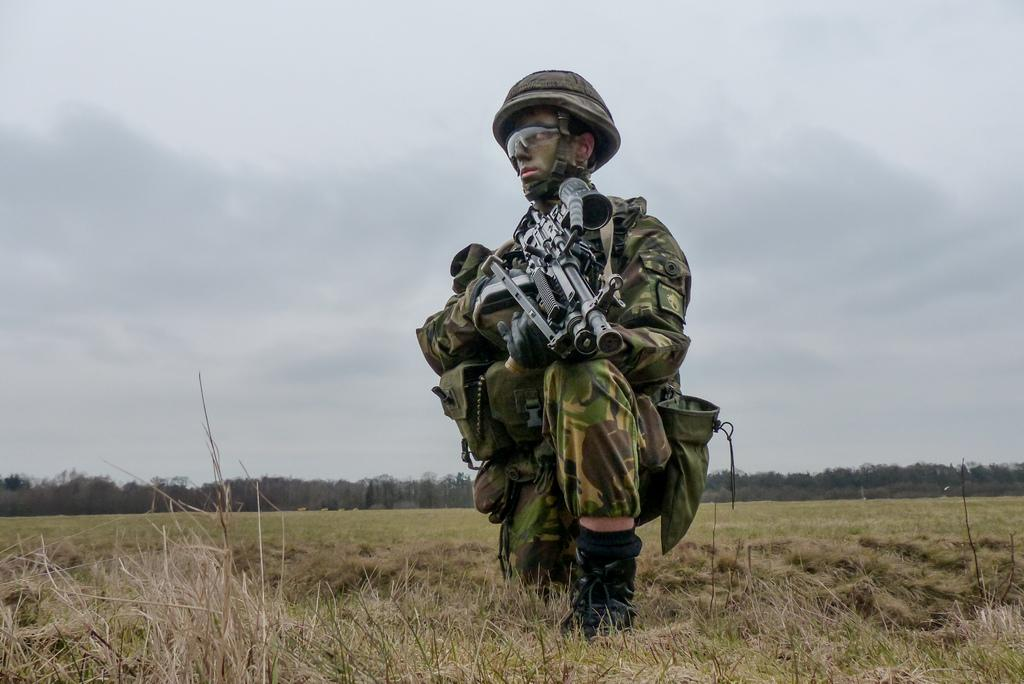Who or what is the main subject in the image? There is a person in the image. What is the person standing on? The person is on a greenery ground. What type of clothing is the person wearing? The person is wearing a military dress. What object is the person holding in their hand? The person is holding a gun in their hand. What can be seen in the background of the image? There are trees in the background of the image. How many cats are visible in the image? There are no cats present in the image. What type of pail is being used by the person in the image? There is no pail visible in the image; the person is holding a gun. 